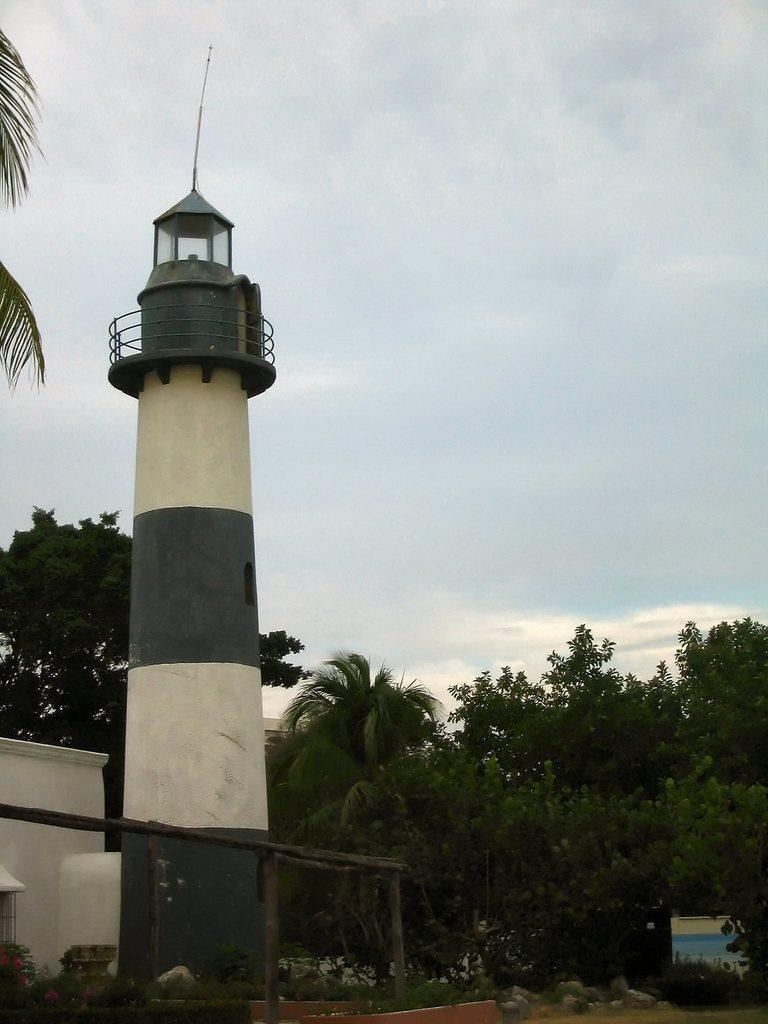What is the main structure in the image? There is a lighthouse in the image. What can be seen in the distance behind the lighthouse? There are trees in the background of the image. What is visible at the bottom of the image? There is ground visible at the bottom of the image. What type of milk is being served at the feast in the image? There is no feast or milk present in the image; it features a lighthouse and trees in the background. Can you describe the fangs of the creature lurking in the shadows of the image? There is no creature or fangs present in the image; it features a lighthouse, trees, and ground. 